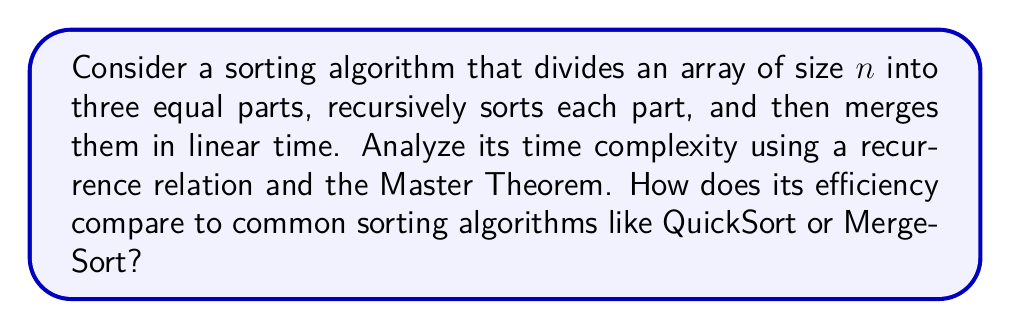Give your solution to this math problem. Let's approach this step-by-step:

1) First, we need to formulate the recurrence relation:
   $T(n) = 3T(n/3) + cn$
   where $c$ is a constant representing the linear time for merging.

2) To apply the Master Theorem, we identify:
   $a = 3$ (number of subproblems)
   $b = 3$ (factor by which problem size is reduced)
   $f(n) = cn$ (cost of dividing and combining)

3) The Master Theorem states that for $T(n) = aT(n/b) + f(n)$:
   If $f(n) = \Theta(n^{\log_b a + \epsilon})$ for some $\epsilon > 0$, then $T(n) = \Theta(f(n))$
   If $f(n) = \Theta(n^{\log_b a})$, then $T(n) = \Theta(n^{\log_b a} \log n)$
   If $f(n) = \Theta(n^{\log_b a - \epsilon})$ for some $\epsilon > 0$, then $T(n) = \Theta(n^{\log_b a})$

4) In our case:
   $\log_b a = \log_3 3 = 1$
   $f(n) = cn = \Theta(n^1)$

5) This matches the second case of the Master Theorem, so:
   $T(n) = \Theta(n^{\log_3 3} \log n) = \Theta(n \log n)$

6) Comparing to other sorting algorithms:
   - QuickSort: Average case $\Theta(n \log n)$, worst case $\Theta(n^2)$
   - MergeSort: $\Theta(n \log n)$ in all cases

Therefore, this algorithm has the same asymptotic time complexity as MergeSort and the average case of QuickSort. However, it may have higher constant factors due to dividing into three parts instead of two, potentially making it slightly less efficient in practice.
Answer: $\Theta(n \log n)$ 